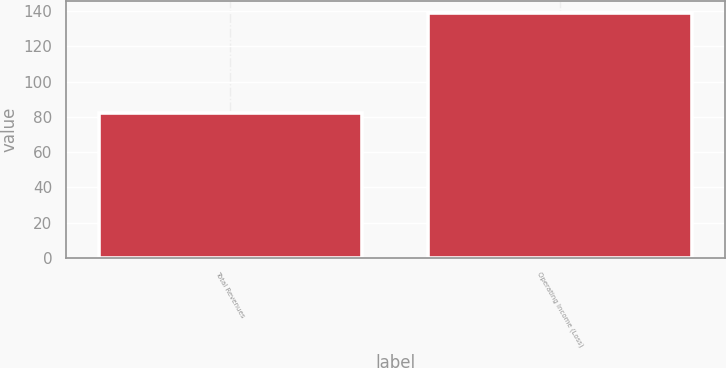<chart> <loc_0><loc_0><loc_500><loc_500><bar_chart><fcel>Total Revenues<fcel>Operating Income (Loss)<nl><fcel>82<fcel>139<nl></chart> 